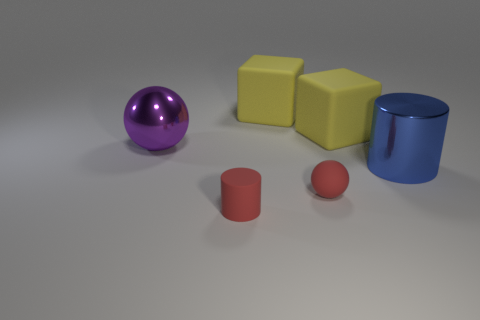Can you describe the shapes and colors of the objects in the image? Certainly! In the image, we have a purple sphere, two yellow cubes, a blue cylinder, and two red cylindrical objects - one is larger and one is much smaller, resembling a ball. 